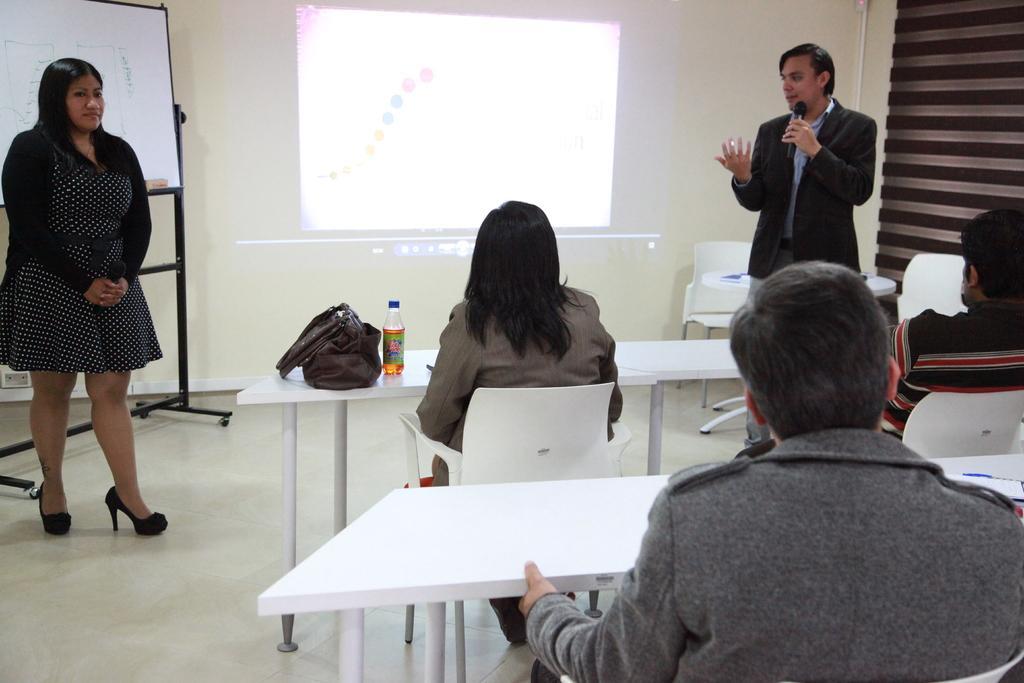How would you summarize this image in a sentence or two? In this image, we can see persons wearing clothes and sitting on chairs in front of tables. There is a person on the left side of the image standing in front of the board. There is an another person on the right side of the image standing in front of chairs. There is a screen at the top of the image. There is a handbag and bottle on the table. 